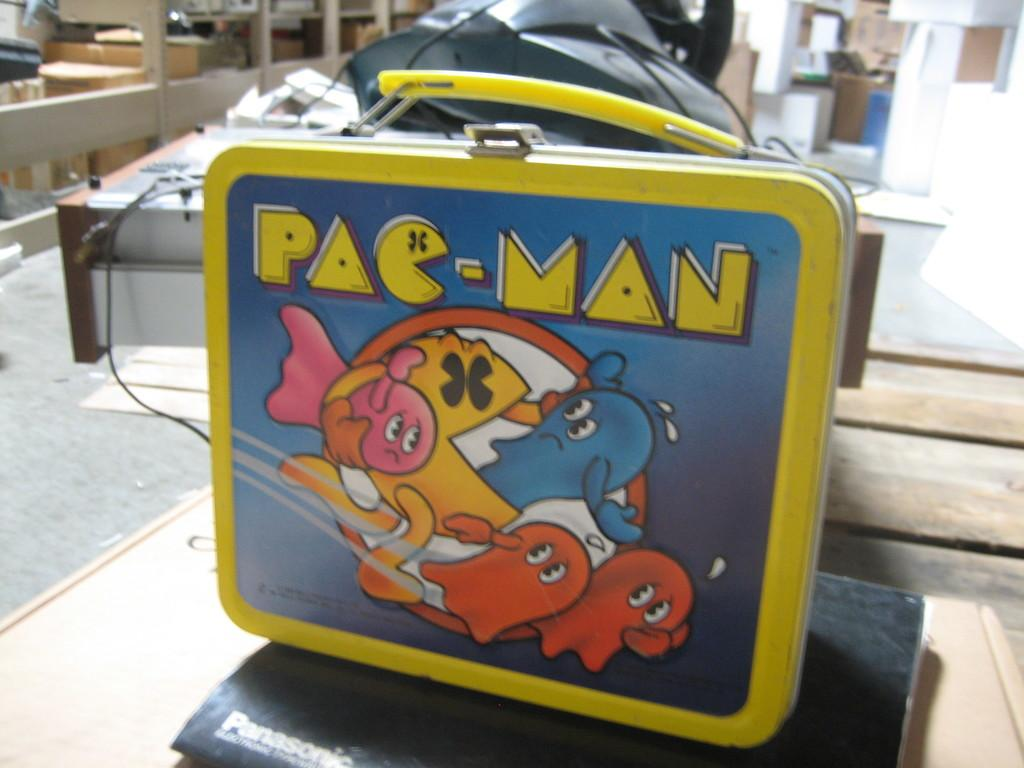What is the box resting on in the image? The box is on a book in the image. Where is the book located? The book is on a surface in the image. What can be seen behind the box? There are objects behind the box in the image. Can you describe any additional details about the image? There is a cable visible in the image, and the background is blurred. Is there a fire visible in the image? No, there is no fire present in the image. Can you see the person's partner in the image? There is no person or partner visible in the image; it only shows a box on a book, objects behind the box, a cable, and a blurred background. 